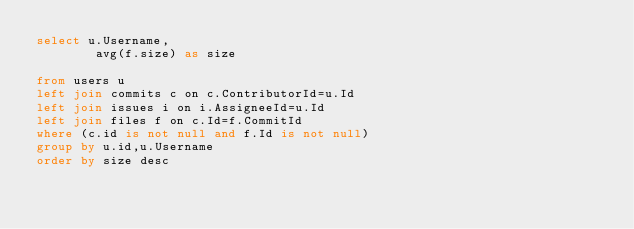Convert code to text. <code><loc_0><loc_0><loc_500><loc_500><_SQL_>select u.Username,
		avg(f.size) as size

from users u 
left join commits c on c.ContributorId=u.Id
left join issues i on i.AssigneeId=u.Id
left join files f on c.Id=f.CommitId
where (c.id is not null and f.Id is not null) 
group by u.id,u.Username
order by size desc
</code> 